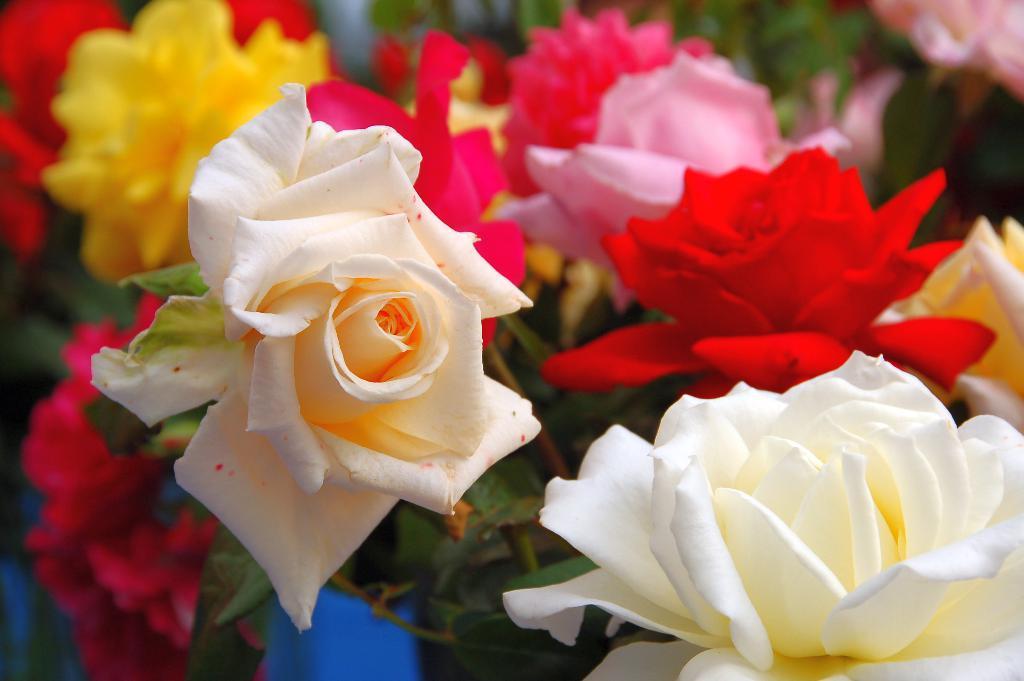In one or two sentences, can you explain what this image depicts? In the picture I can see flowers. These flowers are white, red, pink and yellow in color. 